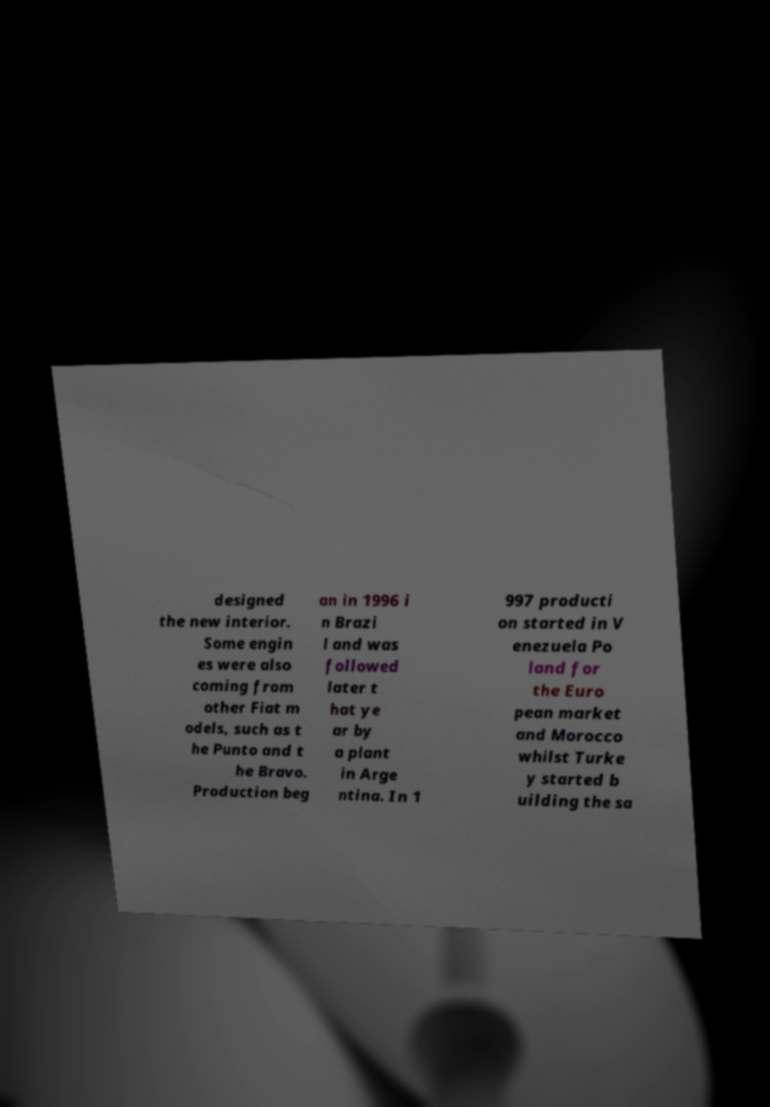Please read and relay the text visible in this image. What does it say? designed the new interior. Some engin es were also coming from other Fiat m odels, such as t he Punto and t he Bravo. Production beg an in 1996 i n Brazi l and was followed later t hat ye ar by a plant in Arge ntina. In 1 997 producti on started in V enezuela Po land for the Euro pean market and Morocco whilst Turke y started b uilding the sa 